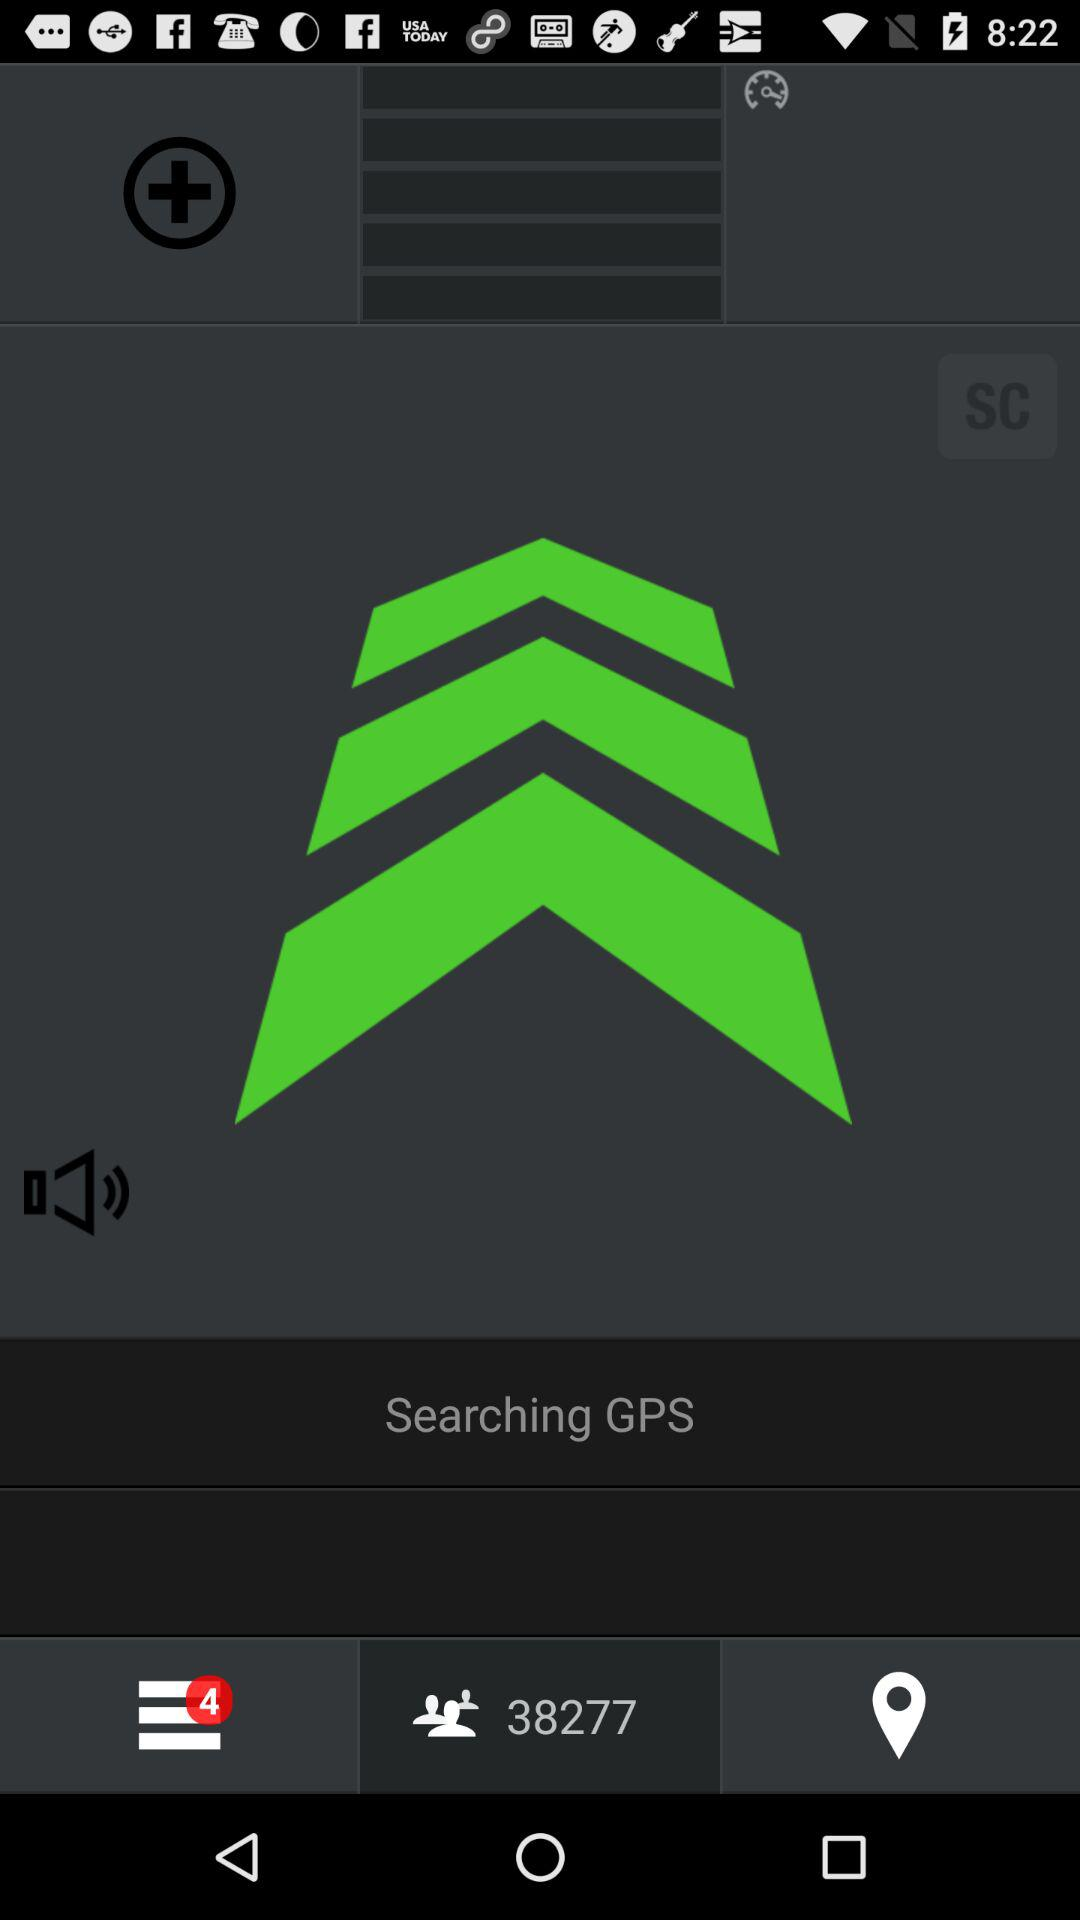How many unread notifications are there in the menu? There are 4 unread notifications in the menu. 